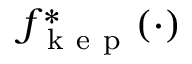Convert formula to latex. <formula><loc_0><loc_0><loc_500><loc_500>f _ { k e p } ^ { * } ( \cdot )</formula> 